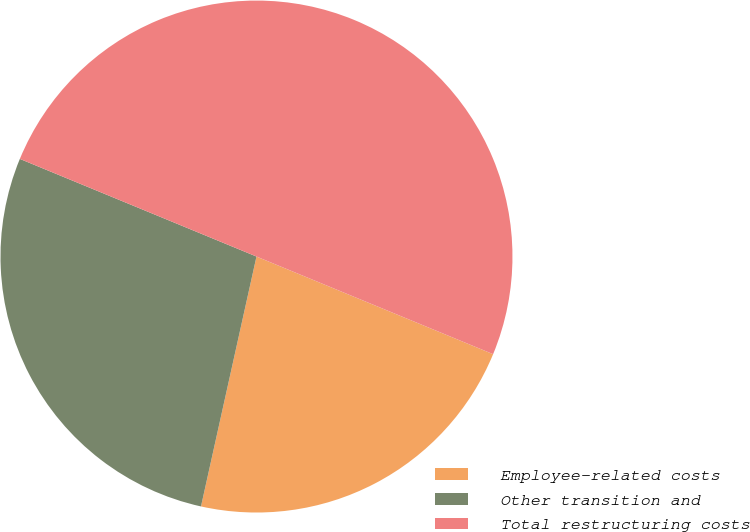<chart> <loc_0><loc_0><loc_500><loc_500><pie_chart><fcel>Employee-related costs<fcel>Other transition and<fcel>Total restructuring costs<nl><fcel>22.25%<fcel>27.75%<fcel>50.0%<nl></chart> 